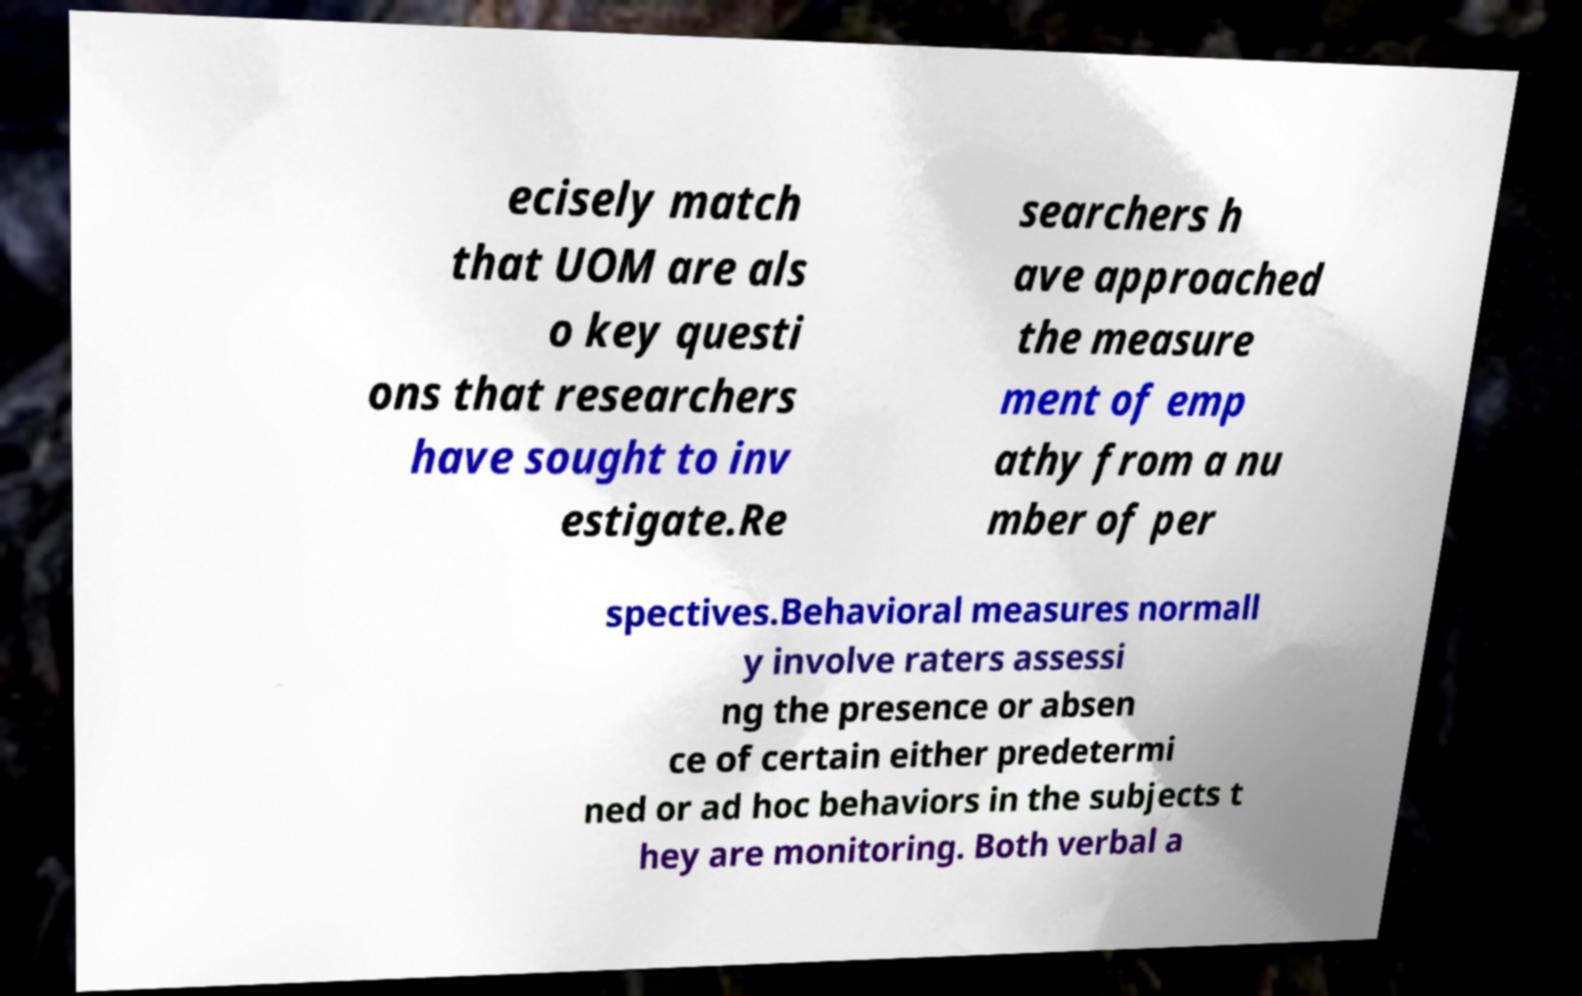For documentation purposes, I need the text within this image transcribed. Could you provide that? ecisely match that UOM are als o key questi ons that researchers have sought to inv estigate.Re searchers h ave approached the measure ment of emp athy from a nu mber of per spectives.Behavioral measures normall y involve raters assessi ng the presence or absen ce of certain either predetermi ned or ad hoc behaviors in the subjects t hey are monitoring. Both verbal a 